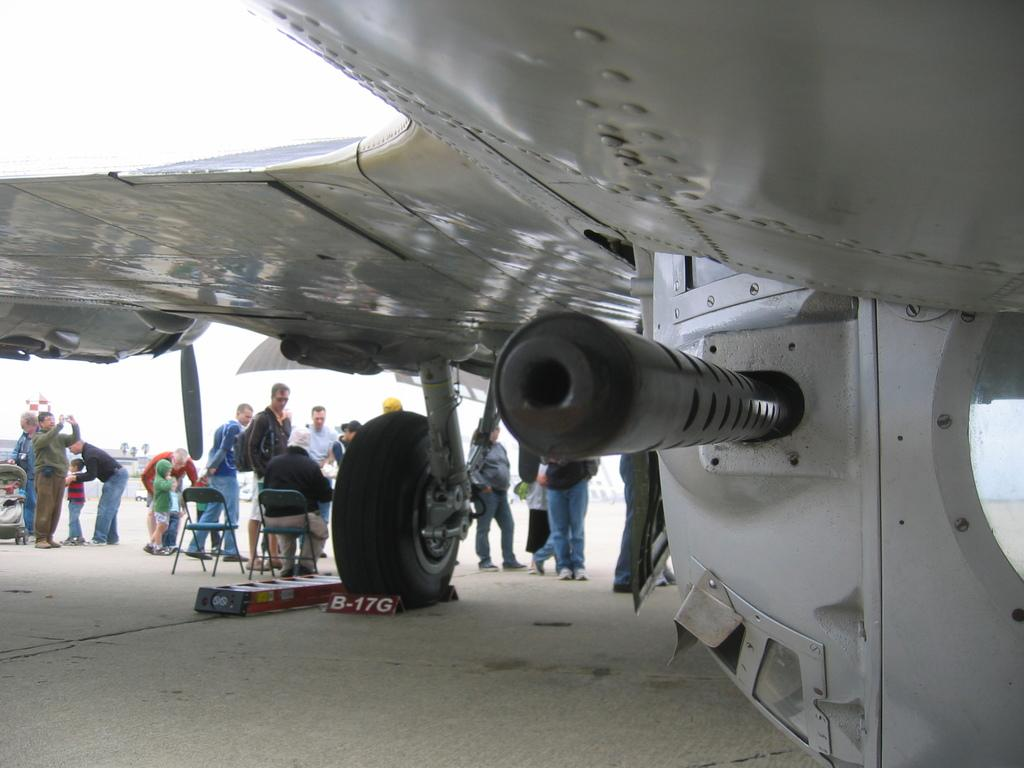<image>
Give a short and clear explanation of the subsequent image. The letters under the large tire read B-17G 